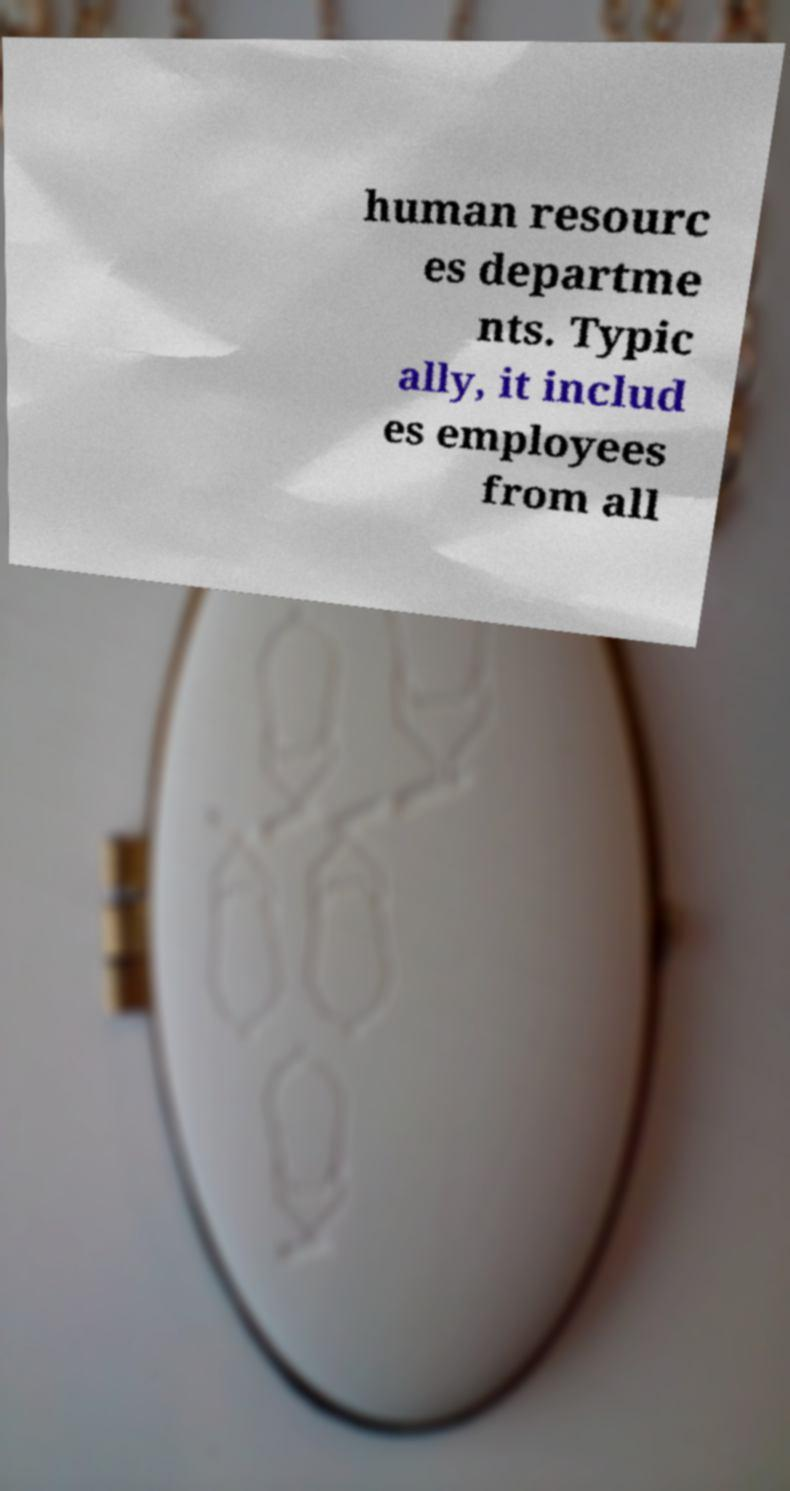Could you extract and type out the text from this image? human resourc es departme nts. Typic ally, it includ es employees from all 